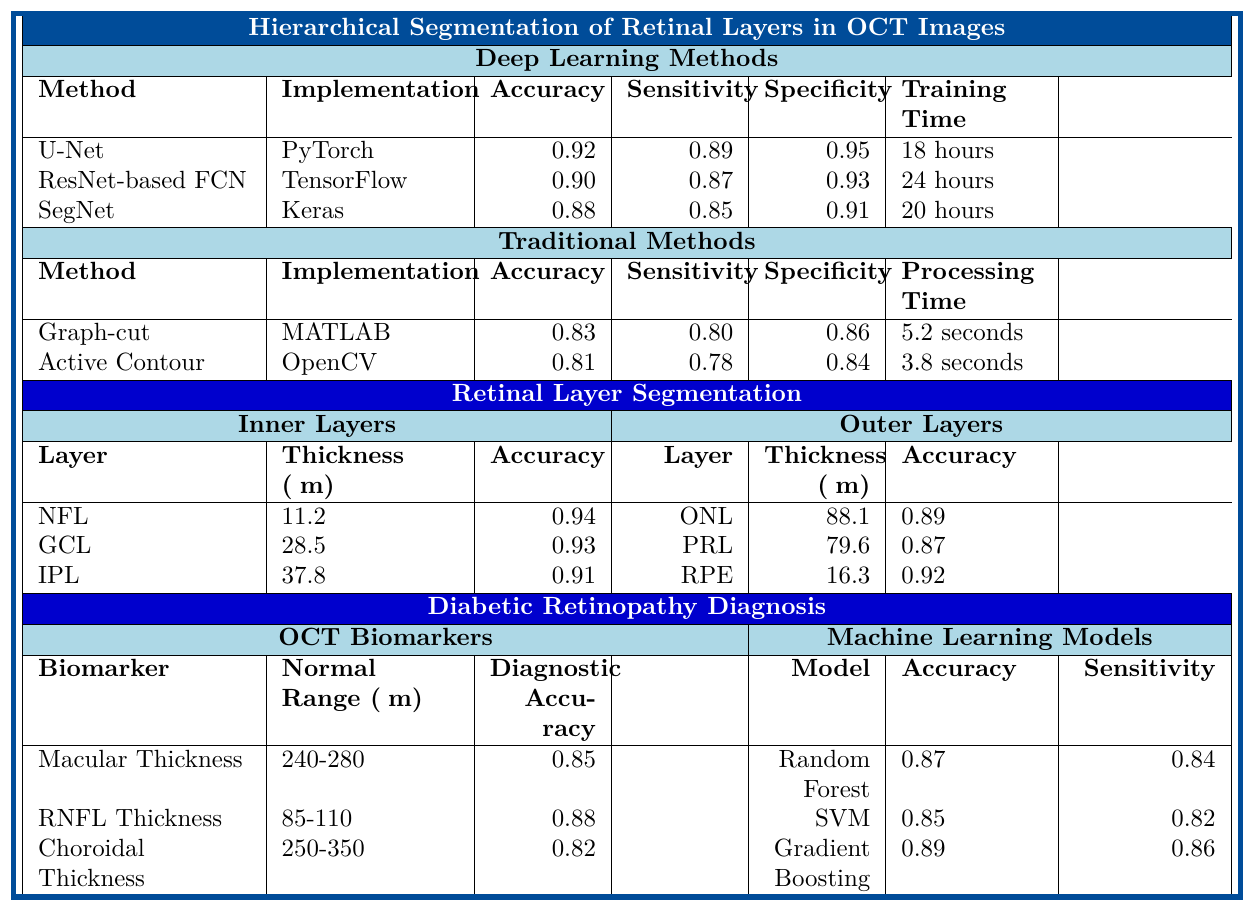What is the accuracy of the U-Net method in retinal layer segmentation? The table shows that the accuracy of the U-Net method is explicitly listed as 0.92.
Answer: 0.92 Which machine learning model has the highest sensitivity? By comparing the sensitivity values listed under the machine learning models, Gradient Boosting has the highest sensitivity at 0.86.
Answer: Gradient Boosting What is the average thickness of the Ganglion Cell Layer? The table indicates that the average thickness of the Ganglion Cell Layer is 28.5 μm.
Answer: 28.5 μm Is the segmentation accuracy of the Ganglion Cell Layer greater than that of the Photoreceptor Layer? The segmentation accuracy for the Ganglion Cell Layer is 0.93, and for the Photoreceptor Layer is 0.87. Since 0.93 > 0.87, the statement is true.
Answer: Yes What is the average sensitivity of the Deep Learning methods? The sensitivities for the three Deep Learning methods are 0.89 (U-Net), 0.87 (ResNet-based FCN), and 0.85 (SegNet). Summing these gives 0.89 + 0.87 + 0.85 = 2.61, and dividing by three gives an average of 2.61 / 3 = 0.87.
Answer: 0.87 Is the processing time for the Active Contour method less than that for the Graph-cut method? The processing time for Active Contour is 3.8 seconds, and for Graph-cut, it is 5.2 seconds. Since 3.8 < 5.2, the statement is true.
Answer: Yes How does the segmentation accuracy of the Retinal Pigment Epithelium compare to that of the Inner Plexiform Layer? The segmentation accuracy of the Retinal Pigment Epithelium is 0.92, while for the Inner Plexiform Layer, it is 0.91. Since 0.92 > 0.91, the Retinal Pigment Epithelium has higher accuracy.
Answer: Higher What is the total diagnostic accuracy for the three OCT biomarkers combined? The diagnostic accuracies for the OCT biomarkers are 0.85 (Macular Thickness), 0.88 (RNFL Thickness), and 0.82 (Choroidal Thickness). Their sum is 0.85 + 0.88 + 0.82 = 2.55, but to find a combined measure, one would typically look for a different metric; here we present the total sum instead.
Answer: 2.55 Which deep learning method has the best specificity, and what is its value? From the table, U-Net has the best specificity at 0.95 compared to the others.
Answer: U-Net, 0.95 What is the difference in average thickness between the Outer Nuclear Layer and the Retinal Pigment Epithelium? The average thickness of the Outer Nuclear Layer is 88.1 μm, and that for the Retinal Pigment Epithelium is 16.3 μm. The difference is 88.1 - 16.3 = 71.8 μm.
Answer: 71.8 μm 